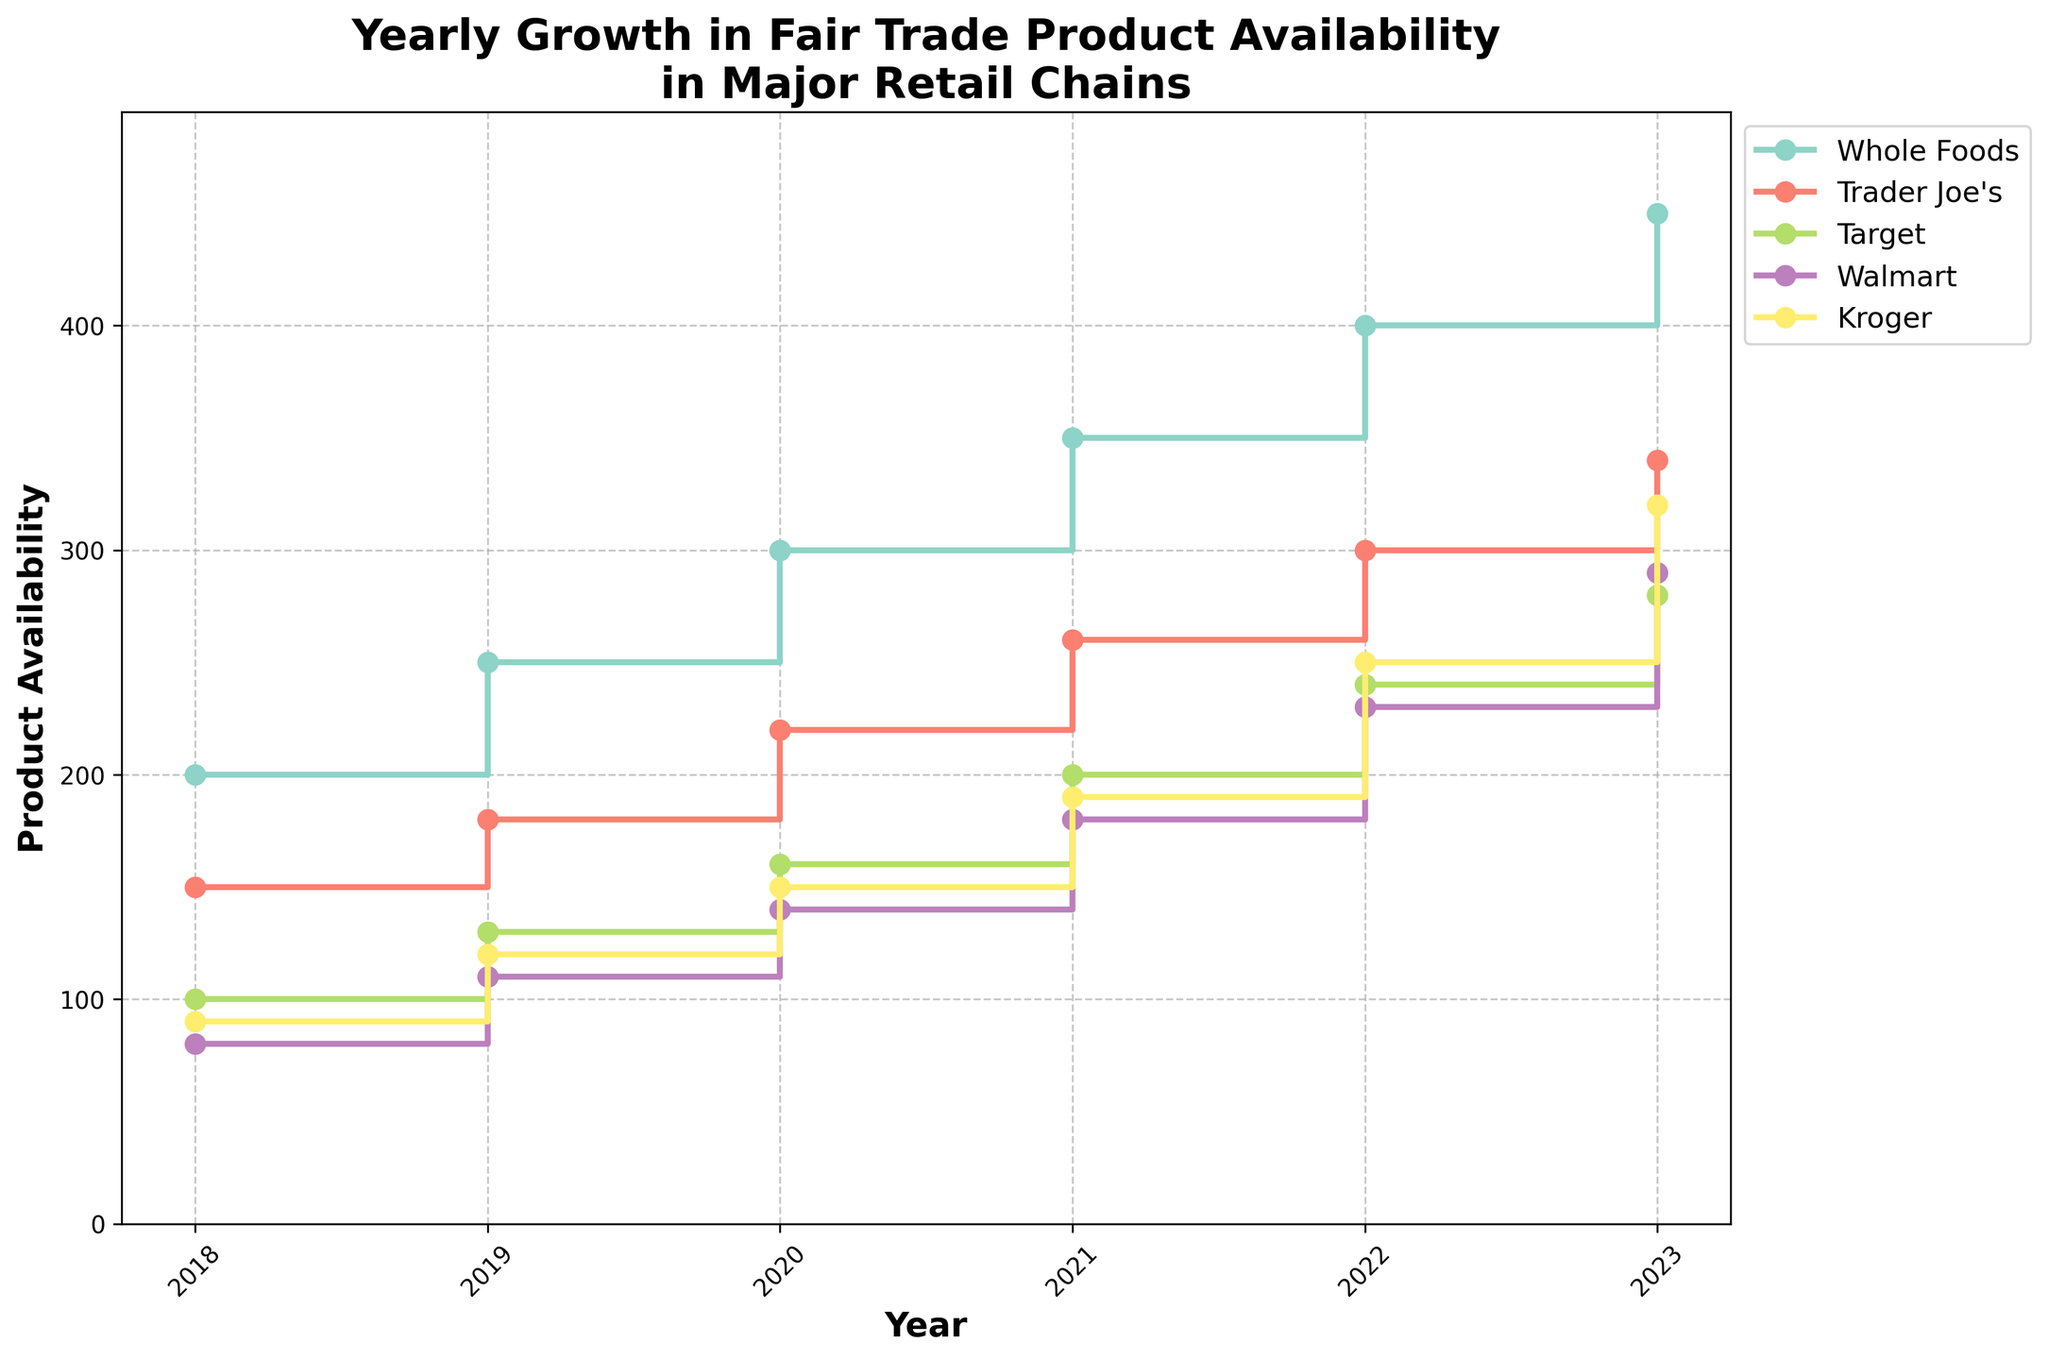What is the title of the figure? The title is usually located at the top of the plot, providing a summary of what the figure is about. In this case, it informs about the yearly growth of fair trade product availability in major retail chains.
Answer: Yearly Growth in Fair Trade Product Availability in Major Retail Chains What is the value of fair trade product availability at Whole Foods in 2019? To find this, look for the line corresponding to Whole Foods (identified by its color and label) and find the point aligned with the year 2019. The figure indicates the numerical value at this point.
Answer: 250 Which retailer shows the highest growth in product availability from 2018 to 2023? To determine this, calculate the difference between the 2023 and 2018 values for each retailer and compare.
Answer: Whole Foods How does the product availability in Trader Joe's in 2021 compare to Target in the same year? Check the values for both Trader Joe's and Target in the year 2021 and compare them visually by locating their respective points on the plot.
Answer: Trader Joe's has higher availability What is the range of product availability values at Walmart from 2018 to 2023? To find the range, determine the maximum and minimum values within the given years for Walmart and subtract the minimum from the maximum. This can be identified by examining the points on Walmart's line.
Answer: 290 - 80 = 210 Among the five retailers, which one had the least product availability in 2022? Inspect the values plotted for the year 2022 for all five retailers and identify the smallest one.
Answer: Walmart Is the trend of product availability for Kroger increasing, decreasing, or stable over the years? Look at the overall direction of the line representing Kroger from 2018 to 2023. If it's moving upwards, it's increasing; if downwards, decreasing; and if it remains horizontal, it's stable.
Answer: Increasing What is the average product availability at Target from 2018 to 2023? Add up the product availability values for Target from each year and divide by the number of years (6).
Answer: (100 + 130 + 160 + 200 + 240 + 280) / 6 = 185 Compare the product availability growth between Trader Joe's and Whole Foods from 2019 to 2023. Which retailer had greater growth? Calculate the difference in values for each retailer between 2019 and 2023 and then compare the two differences. Whole Foods growth: 450 - 250 = 200; Trader Joe's growth: 340 - 180 = 160.
Answer: Whole Foods What year did Kroger's product availability reach 190? Locate the point on Kroger's line where the value is 190 and refer to the corresponding year on the x-axis.
Answer: 2021 